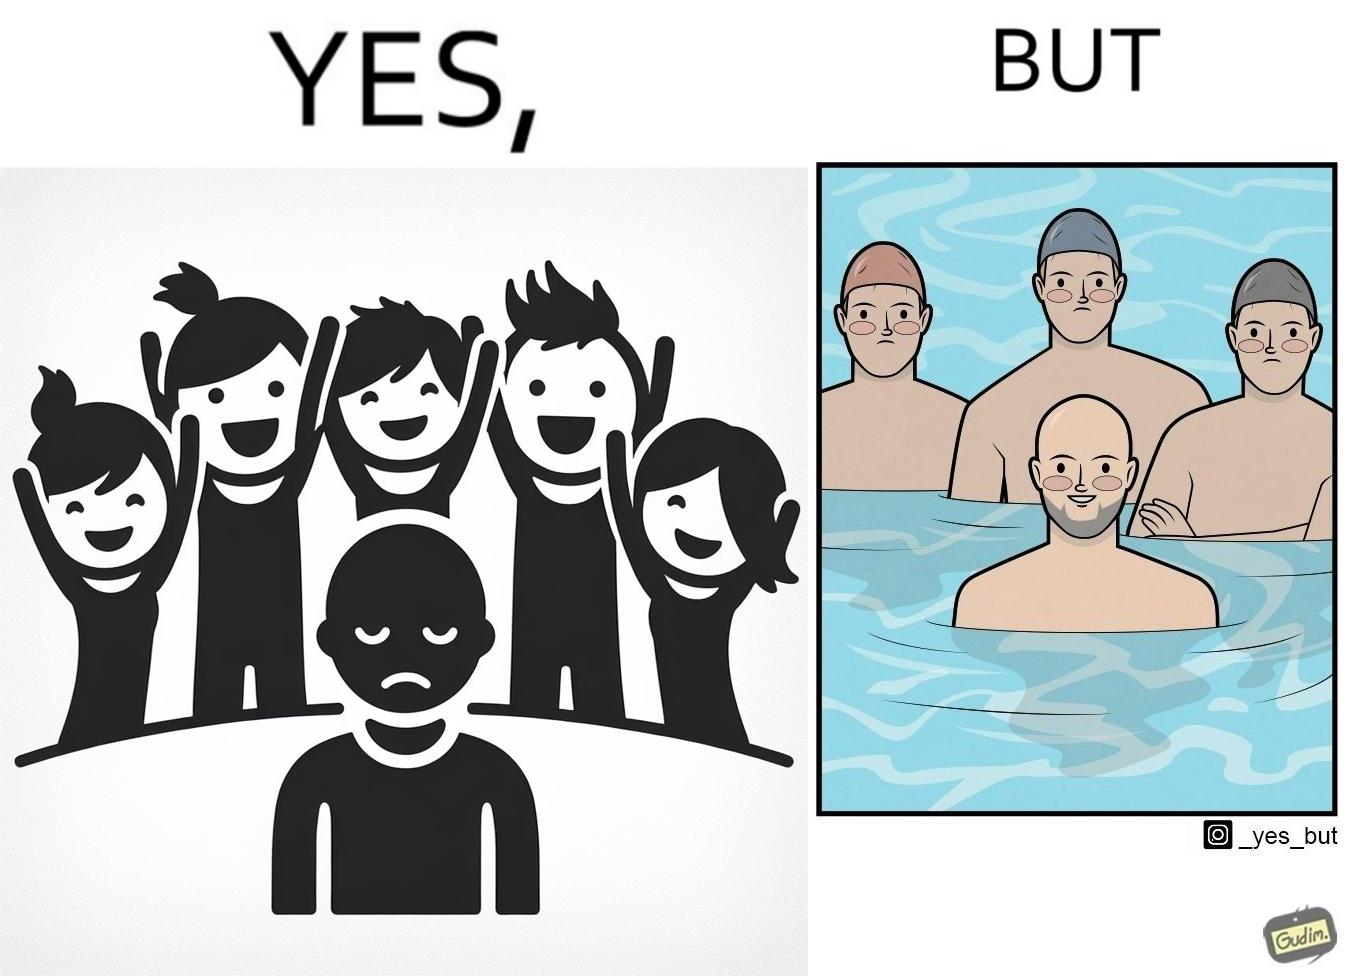Describe the contrast between the left and right parts of this image. In the left part of the image: Three happy people with heads full of hair standing behind a sad person with no hair. In the right part of the image: Three sad people wearing swimming caps standing behind a happy person with no hair in a swimming pool. 